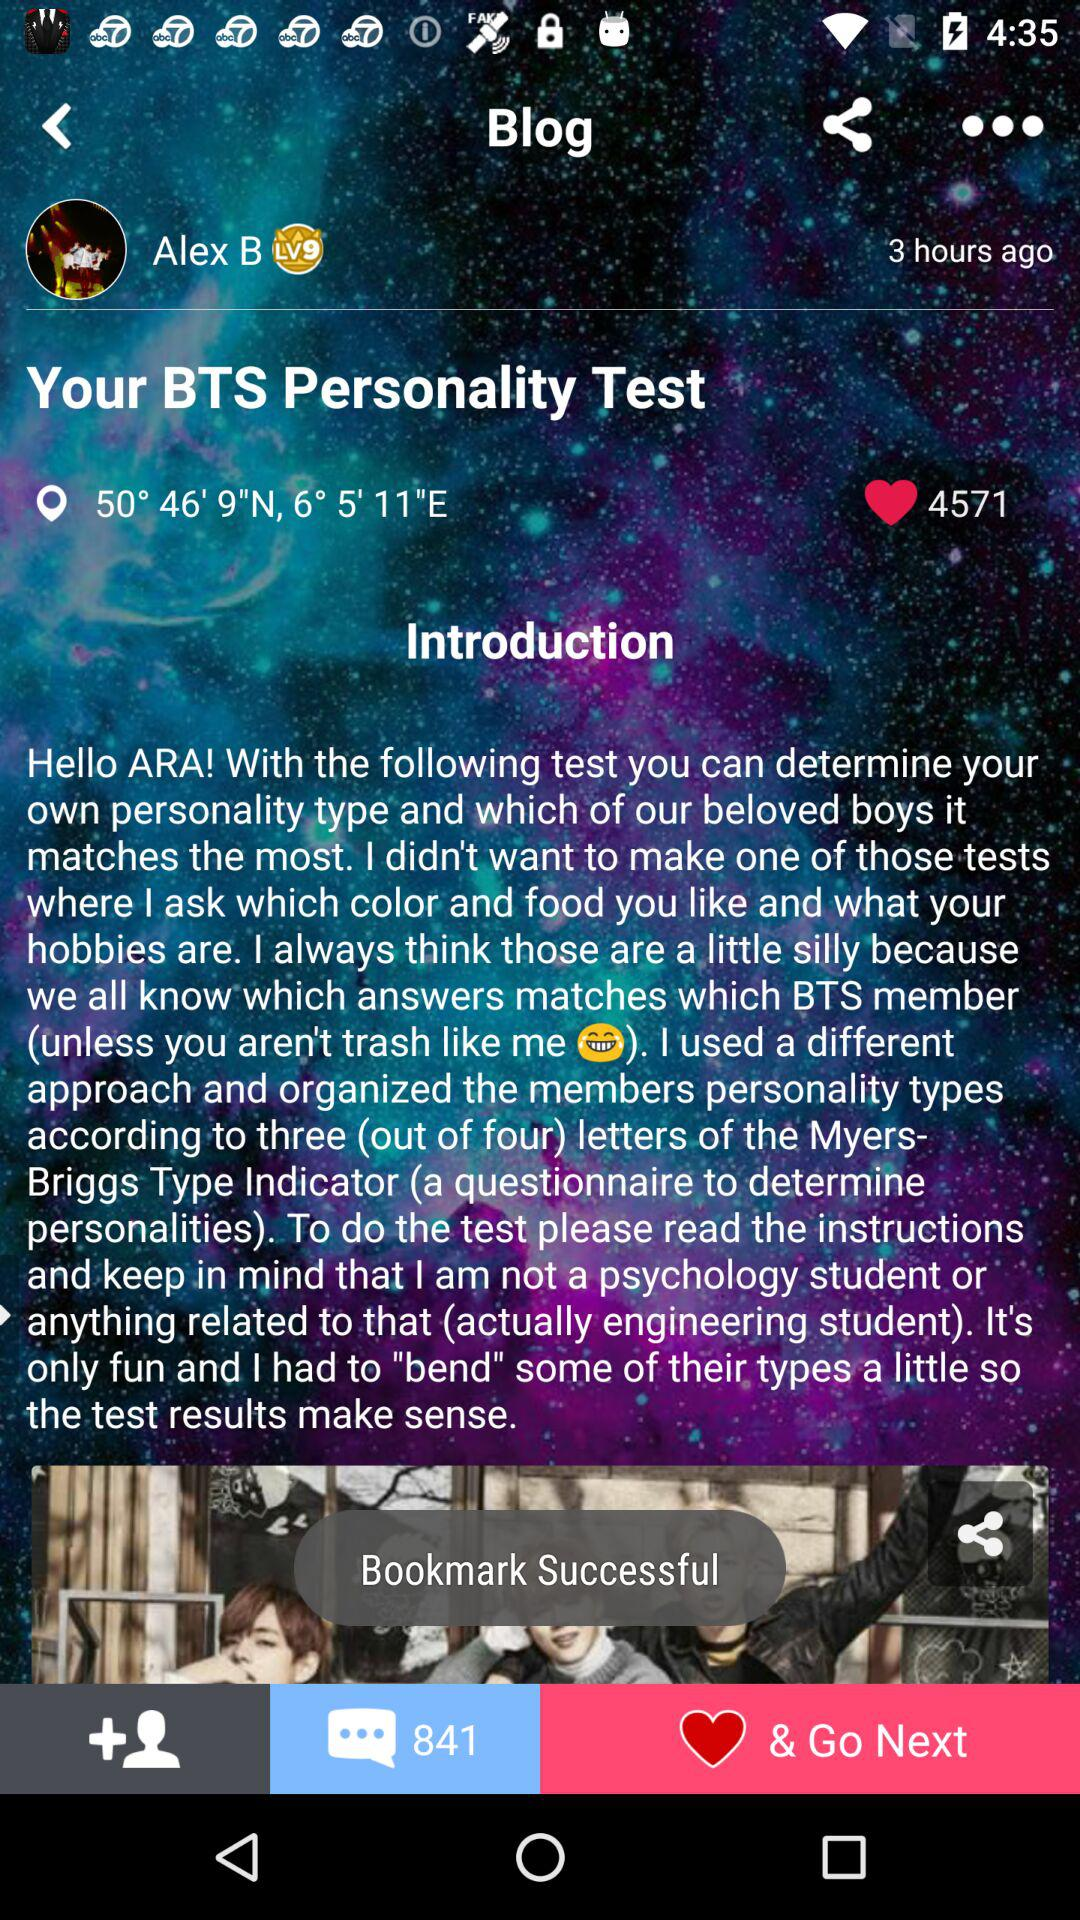What are the given location coordinates? The given coordinates are 50° 46' 9"N, 6° 5' 11" E. 